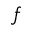<formula> <loc_0><loc_0><loc_500><loc_500>f</formula> 